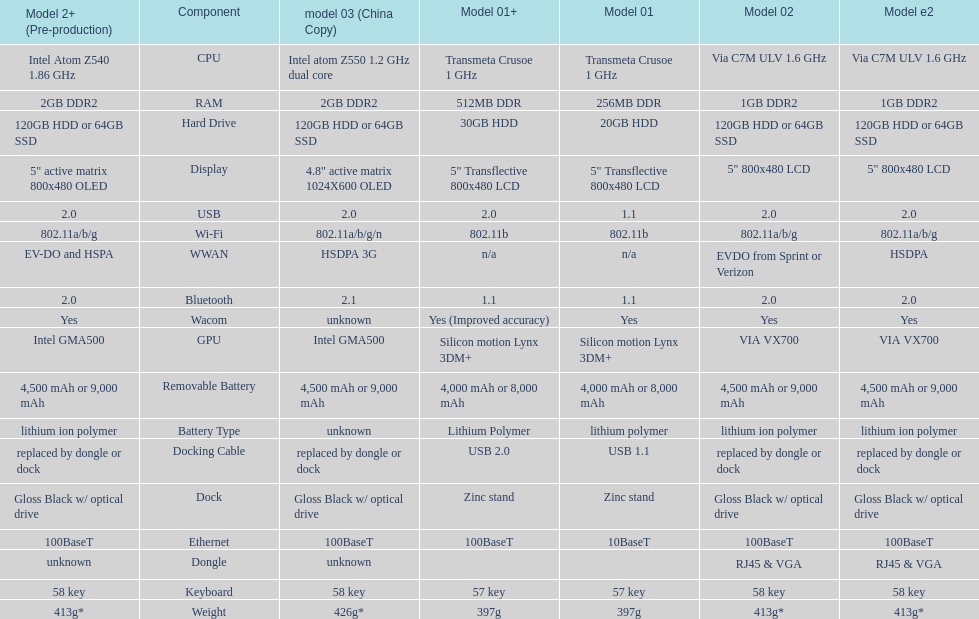How many models have 1.6ghz? 2. 